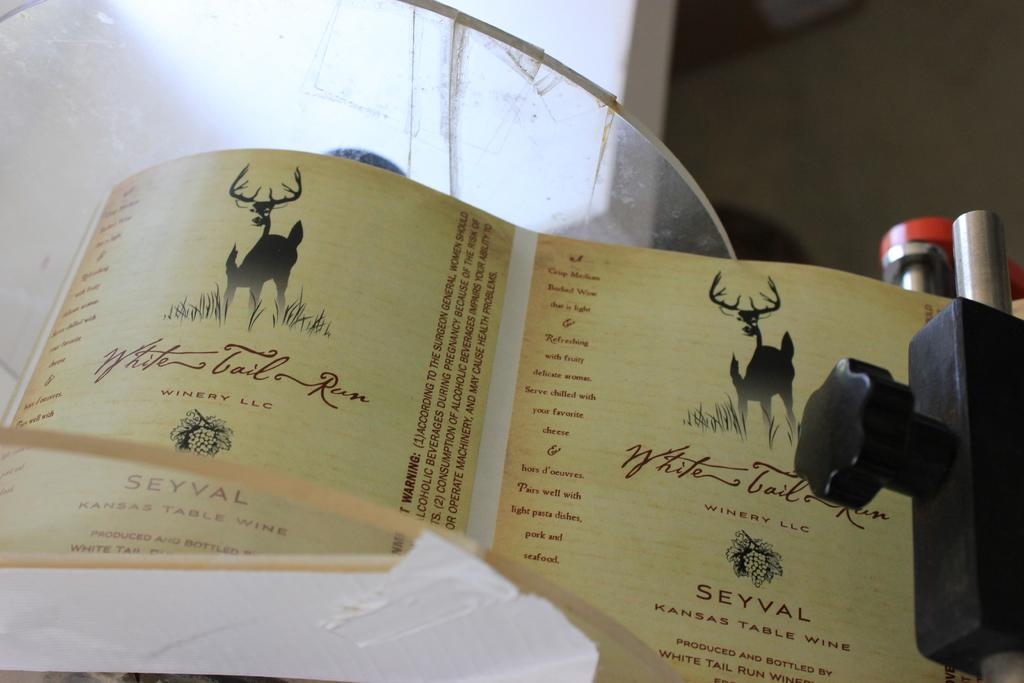<image>
Write a terse but informative summary of the picture. The name of the company depicted on the paper is called "Winery LLC." 